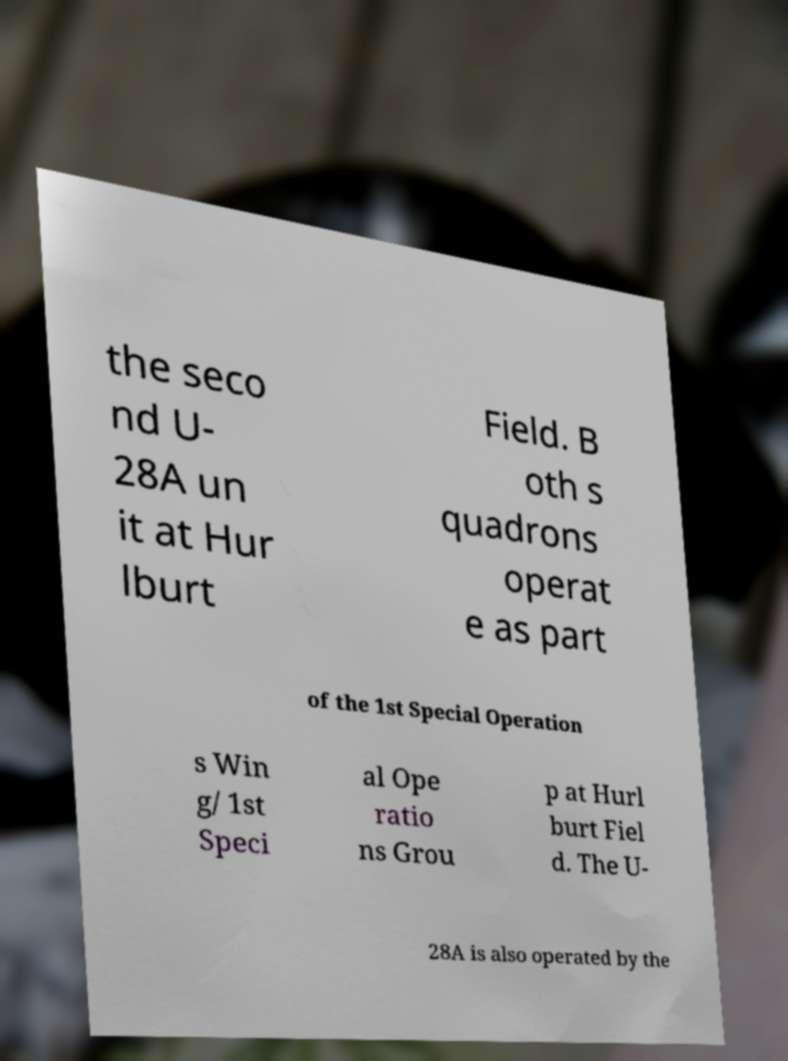Could you extract and type out the text from this image? the seco nd U- 28A un it at Hur lburt Field. B oth s quadrons operat e as part of the 1st Special Operation s Win g/ 1st Speci al Ope ratio ns Grou p at Hurl burt Fiel d. The U- 28A is also operated by the 